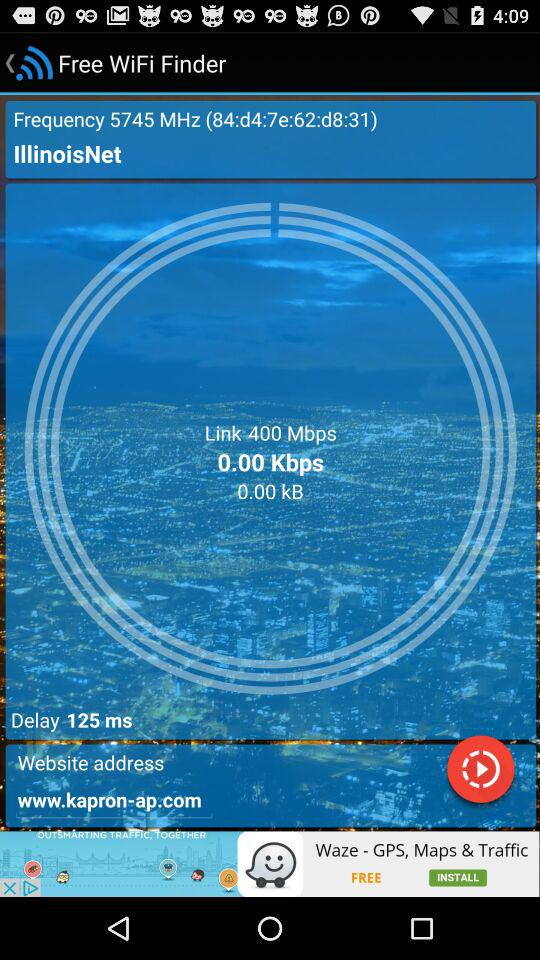How much is the delay? The delay is about 125 ms. 